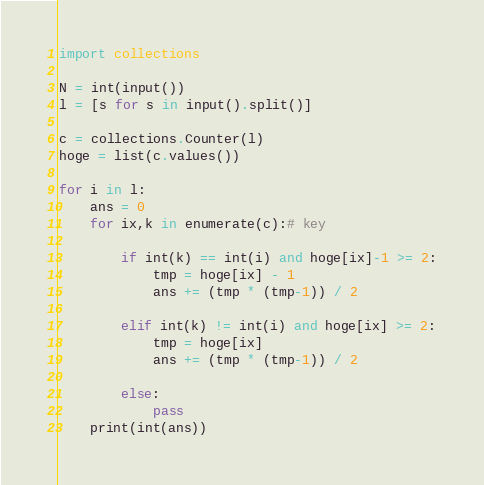Convert code to text. <code><loc_0><loc_0><loc_500><loc_500><_Python_>import collections

N = int(input())
l = [s for s in input().split()]

c = collections.Counter(l)
hoge = list(c.values())

for i in l:
    ans = 0
    for ix,k in enumerate(c):# key
        
        if int(k) == int(i) and hoge[ix]-1 >= 2:
            tmp = hoge[ix] - 1
            ans += (tmp * (tmp-1)) / 2
            
        elif int(k) != int(i) and hoge[ix] >= 2:
            tmp = hoge[ix]
            ans += (tmp * (tmp-1)) / 2
            
        else:
            pass
    print(int(ans))</code> 